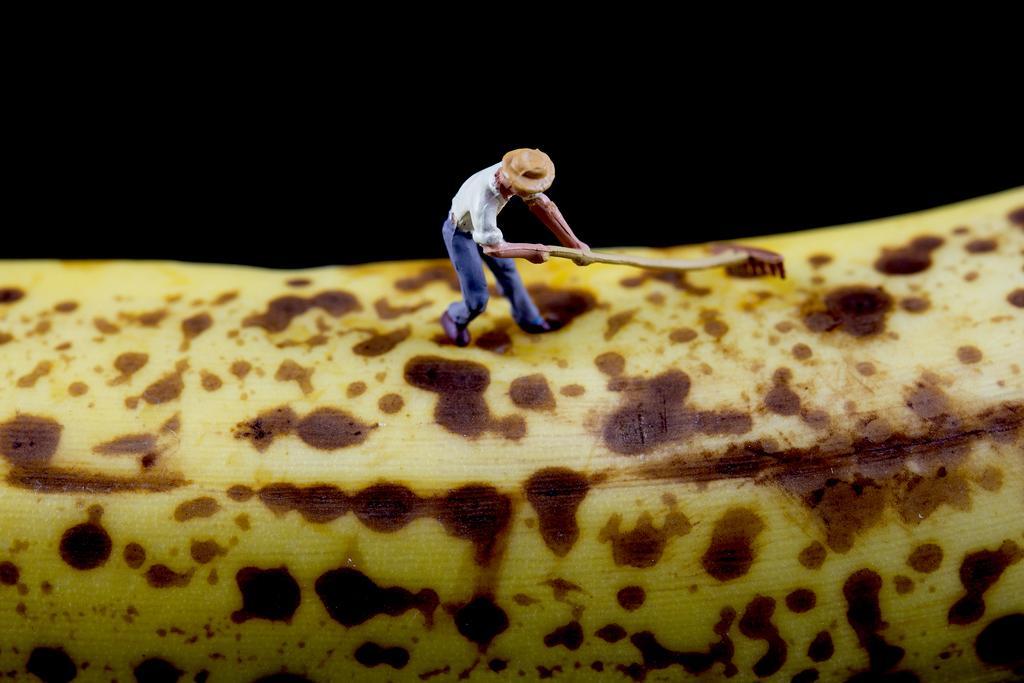In one or two sentences, can you explain what this image depicts? In this image we can see a man holding something in the hand. In the background it is dark. At the bottom there is a yellow object with brown spots on that. And this is an animated image. 